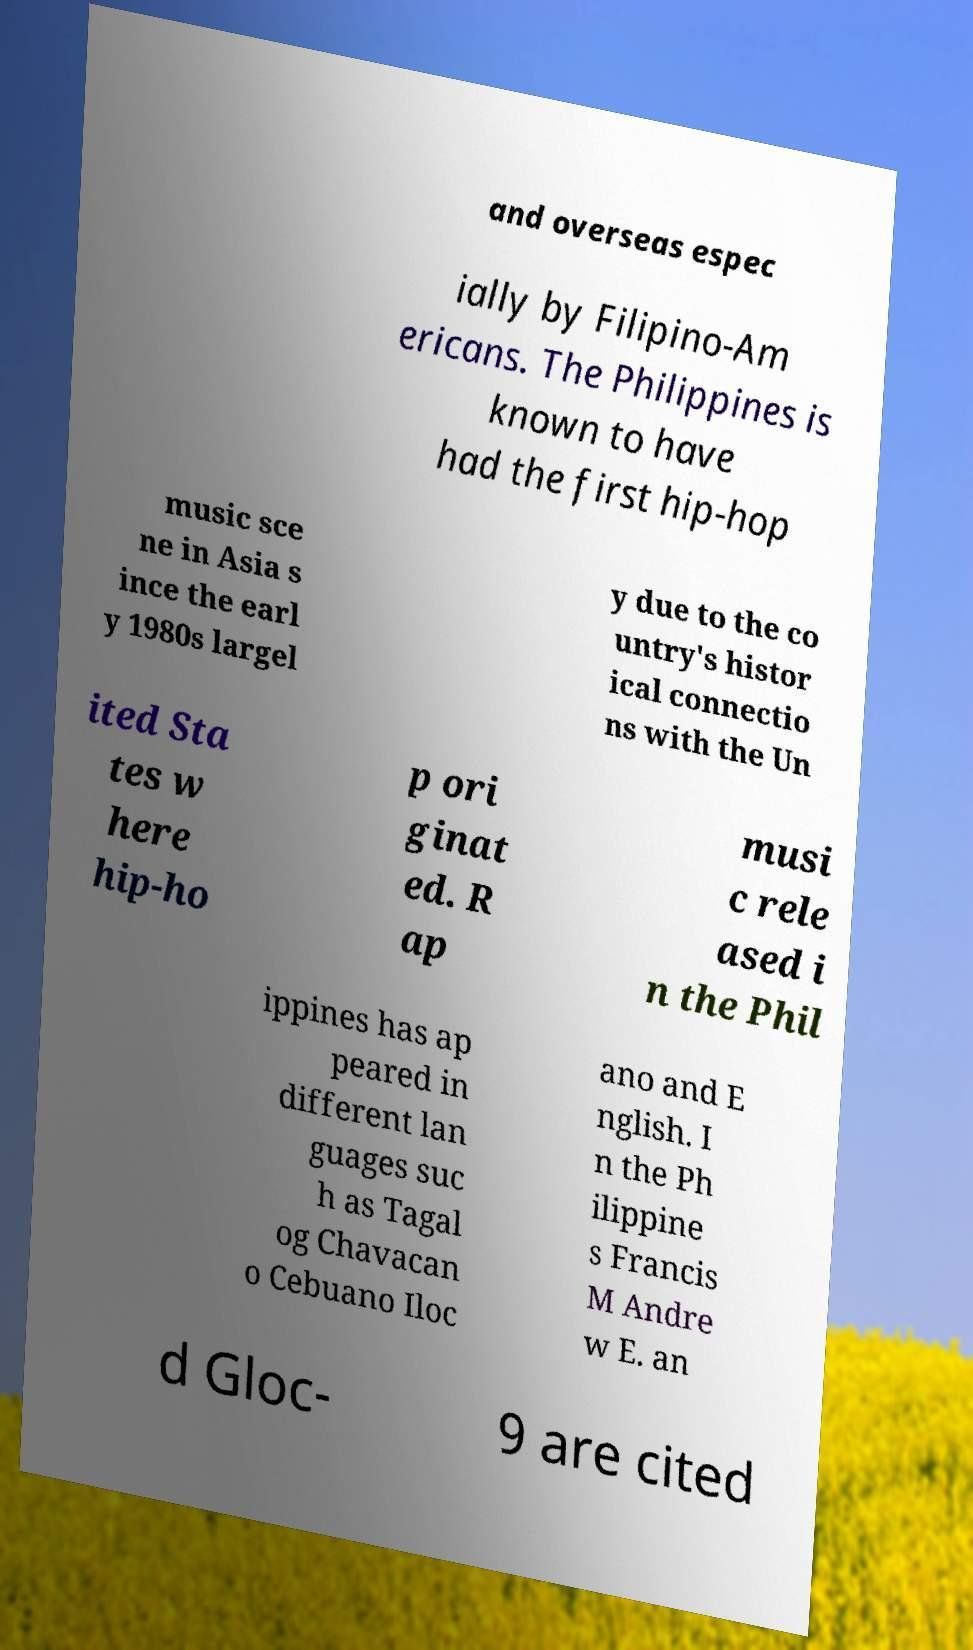There's text embedded in this image that I need extracted. Can you transcribe it verbatim? and overseas espec ially by Filipino-Am ericans. The Philippines is known to have had the first hip-hop music sce ne in Asia s ince the earl y 1980s largel y due to the co untry's histor ical connectio ns with the Un ited Sta tes w here hip-ho p ori ginat ed. R ap musi c rele ased i n the Phil ippines has ap peared in different lan guages suc h as Tagal og Chavacan o Cebuano Iloc ano and E nglish. I n the Ph ilippine s Francis M Andre w E. an d Gloc- 9 are cited 